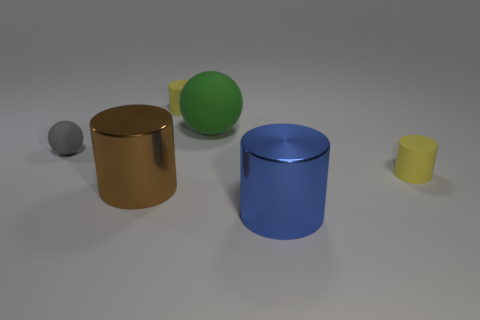What is the material of the blue thing that is the same size as the brown metallic thing?
Offer a very short reply. Metal. Is the number of gray rubber things to the left of the big brown metal object less than the number of tiny rubber cylinders in front of the blue shiny cylinder?
Keep it short and to the point. No. The tiny gray thing in front of the yellow thing behind the large green ball is what shape?
Your answer should be compact. Sphere. Are there any large green metal spheres?
Keep it short and to the point. No. What is the color of the small cylinder that is in front of the tiny gray rubber object?
Provide a succinct answer. Yellow. There is a big green thing; are there any rubber cylinders to the right of it?
Offer a terse response. Yes. Are there more big purple metal spheres than big metal cylinders?
Provide a succinct answer. No. There is a matte cylinder left of the matte cylinder on the right side of the metallic cylinder in front of the brown shiny object; what is its color?
Your answer should be compact. Yellow. The large thing that is the same material as the gray ball is what color?
Give a very brief answer. Green. Is there any other thing that has the same size as the blue metal cylinder?
Keep it short and to the point. Yes. 